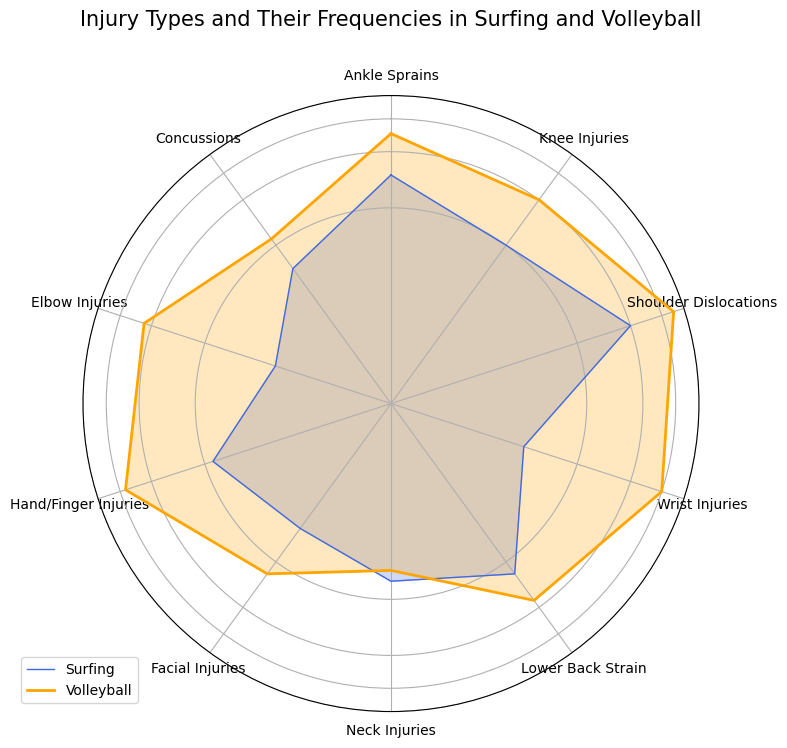Which injury type has the highest frequency in Volleyball? The shoulder dislocations category has the highest frequency in Volleyball, as indicated by the height of the orange fill at the respective angle.
Answer: Shoulder Dislocations Which injury type is equally frequent in both Surfing and Volleyball? The neck injuries category has nearly equal frequency in both Surfing and Volleyball, as indicated by similar heights of the blue and orange fills at the respective angle.
Answer: Neck Injuries For which injury type is the frequency of occurrence in Surfing greater than in Volleyball? By comparing the blue and orange fills at each angle, the shoulder dislocations category has a higher frequency in Surfing compared to Volleyball.
Answer: Shoulder Dislocations What is the combined frequency of knee injuries in both sports? The frequency of knee injuries in Surfing is 10, and in Volleyball is 20. Adding these values gives us a combined frequency of 30.
Answer: 30 Which injury type has the smallest difference in frequency between Surfing and Volleyball? Neck injuries show the smallest difference in frequencies for Surfing and Volleyball, with values of 8 and 7 respectively, yielding a difference of 1.
Answer: Neck Injuries Which injury types have a frequency in Volleyball greater than 20? By examining the heights of the orange fills, the injury types that have frequencies greater than 20 in Volleyball are ankle sprains, shoulder dislocations, wrist injuries, hand/finger injuries, and elbow injuries.
Answer: Ankle Sprains, Shoulder Dislocations, Wrist Injuries, Hand/Finger Injuries, Elbow Injuries Which injuries have higher frequencies in Volleyball than in Surfing? Comparing the heights of the orange and blue fills for each angle, the injury types with higher frequencies in Volleyball are ankle sprains, knee injuries, shoulder dislocations, wrist injuries, lower back strain, facial injuries, hand/finger injuries, elbow injuries, and concussions.
Answer: Most injuries except Shoulder Dislocations and Neck Injuries Are there any injury types with zero frequency in either sport? By inspecting the plots, no injury type has a zero frequency in either sport as all categories have non-zero lengths of blue and orange fills.
Answer: None What’s the total frequency of injuries in Volleyball for ankle sprains and knee injuries? The frequencies for ankle sprains and knee injuries in Volleyball are 25 and 20, respectively. Adding these yields a total frequency of 45.
Answer: 45 In which sport is the total number of wrist injuries higher? The plot shows the height of the orange fill for wrist injuries is taller than the blue fill, indicating that volleyball has a higher total number of wrist injuries.
Answer: Volleyball 